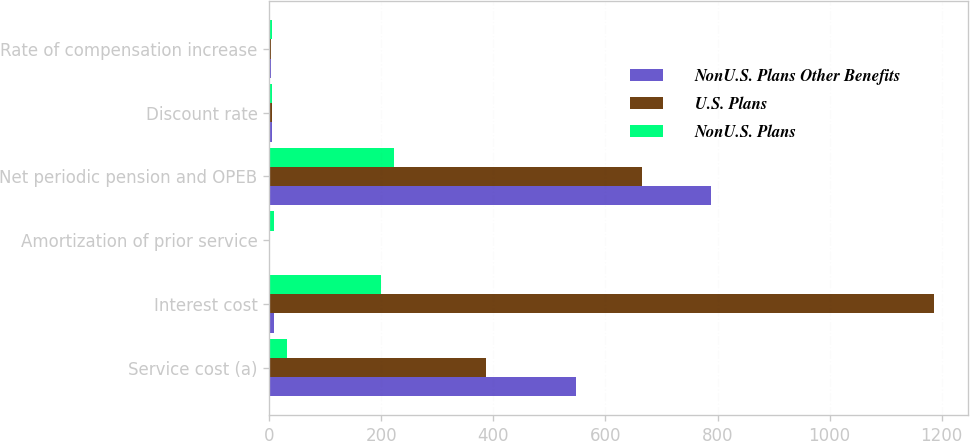<chart> <loc_0><loc_0><loc_500><loc_500><stacked_bar_chart><ecel><fcel>Service cost (a)<fcel>Interest cost<fcel>Amortization of prior service<fcel>Net periodic pension and OPEB<fcel>Discount rate<fcel>Rate of compensation increase<nl><fcel>NonU.S. Plans Other Benefits<fcel>548<fcel>9<fcel>1<fcel>789<fcel>4.96<fcel>3.96<nl><fcel>U.S. Plans<fcel>386<fcel>1187<fcel>1<fcel>666<fcel>5.09<fcel>3.25<nl><fcel>NonU.S. Plans<fcel>32<fcel>200<fcel>9<fcel>223<fcel>4.97<fcel>4.33<nl></chart> 